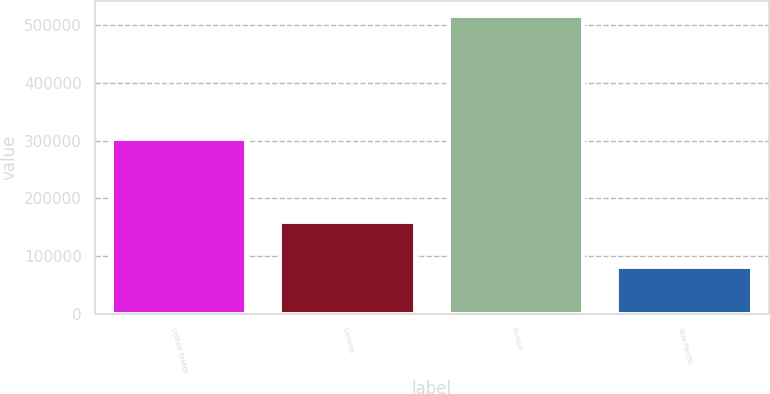Convert chart to OTSL. <chart><loc_0><loc_0><loc_500><loc_500><bar_chart><fcel>United States<fcel>Canada<fcel>Europe<fcel>Asia-Pacific<nl><fcel>302048<fcel>158978<fcel>516093<fcel>80976<nl></chart> 